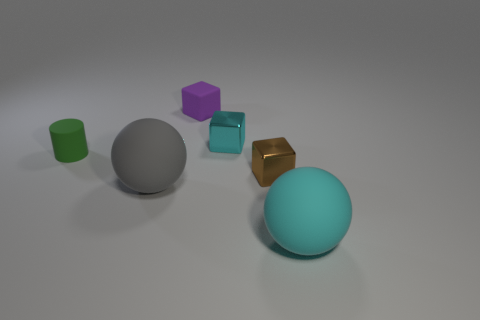What color is the small block that is the same material as the small cyan object?
Offer a terse response. Brown. Does the cube in front of the green matte thing have the same size as the block to the left of the cyan metal object?
Your answer should be compact. Yes. There is another thing that is the same shape as the big gray object; what is its color?
Your answer should be compact. Cyan. Is there any other thing that has the same shape as the small green thing?
Ensure brevity in your answer.  No. Are there more objects behind the big cyan rubber sphere than tiny brown shiny cubes that are behind the brown thing?
Give a very brief answer. Yes. There is a ball that is to the right of the big gray ball left of the block in front of the cyan metal object; how big is it?
Your answer should be very brief. Large. Is the material of the large cyan sphere the same as the cyan object that is left of the brown metallic object?
Make the answer very short. No. Is the cyan rubber thing the same shape as the big gray thing?
Offer a very short reply. Yes. What number of other objects are the same material as the tiny green cylinder?
Make the answer very short. 3. How many other metallic things have the same shape as the tiny brown metal object?
Your response must be concise. 1. 